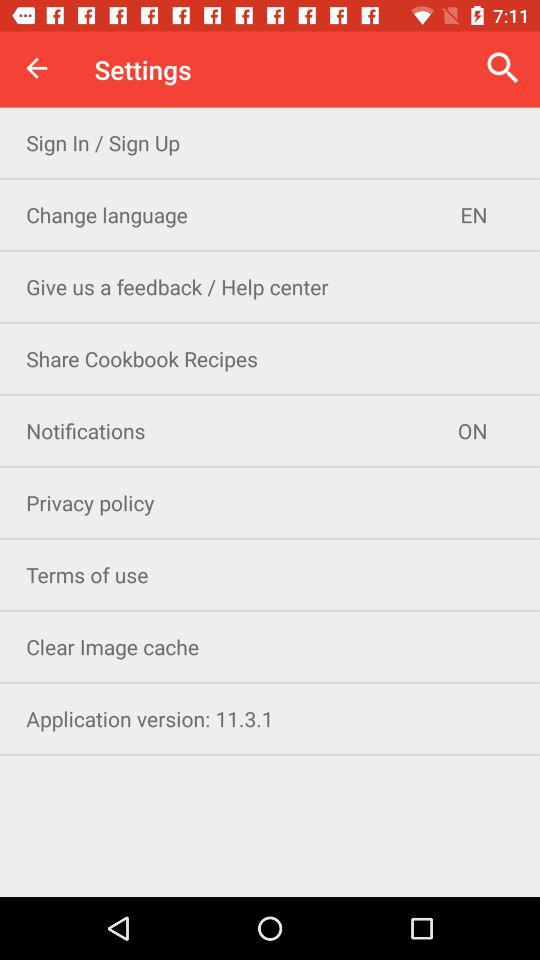What is the selected language? The selected language is "EN". 